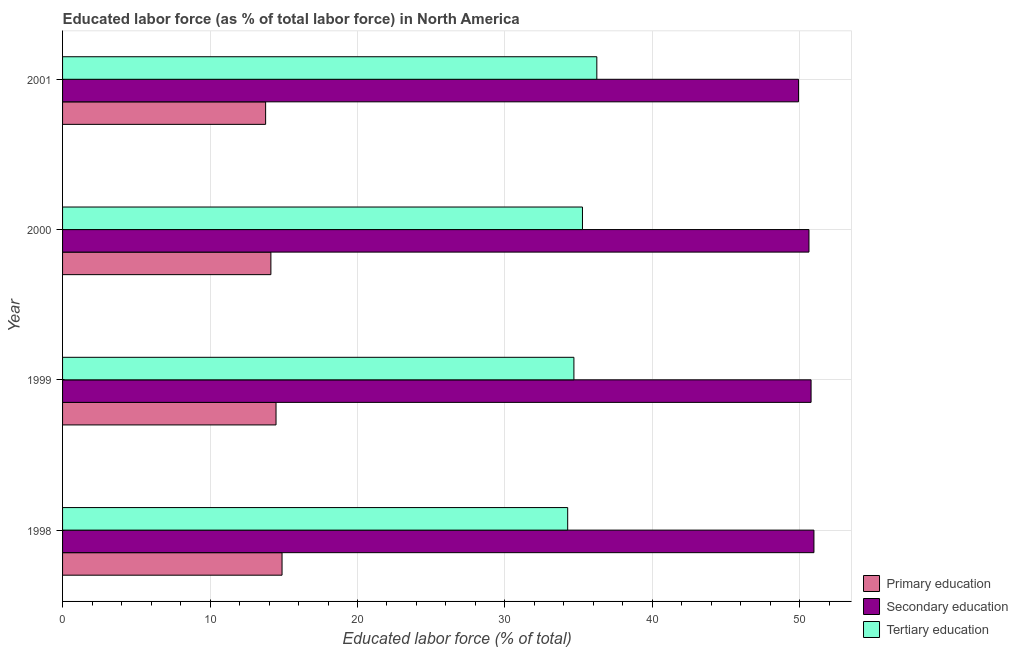How many bars are there on the 3rd tick from the top?
Provide a short and direct response. 3. How many bars are there on the 4th tick from the bottom?
Offer a very short reply. 3. What is the label of the 1st group of bars from the top?
Your answer should be very brief. 2001. What is the percentage of labor force who received primary education in 1999?
Provide a short and direct response. 14.48. Across all years, what is the maximum percentage of labor force who received secondary education?
Your answer should be very brief. 50.95. Across all years, what is the minimum percentage of labor force who received primary education?
Give a very brief answer. 13.77. In which year was the percentage of labor force who received primary education maximum?
Give a very brief answer. 1998. What is the total percentage of labor force who received secondary education in the graph?
Keep it short and to the point. 202.24. What is the difference between the percentage of labor force who received primary education in 1999 and that in 2001?
Provide a succinct answer. 0.7. What is the difference between the percentage of labor force who received tertiary education in 2001 and the percentage of labor force who received secondary education in 2000?
Provide a short and direct response. -14.39. What is the average percentage of labor force who received secondary education per year?
Give a very brief answer. 50.56. In the year 1999, what is the difference between the percentage of labor force who received tertiary education and percentage of labor force who received secondary education?
Your response must be concise. -16.08. What is the ratio of the percentage of labor force who received secondary education in 1998 to that in 2000?
Provide a succinct answer. 1.01. Is the percentage of labor force who received tertiary education in 1999 less than that in 2001?
Ensure brevity in your answer.  Yes. What is the difference between the highest and the second highest percentage of labor force who received secondary education?
Your answer should be compact. 0.19. What is the difference between the highest and the lowest percentage of labor force who received secondary education?
Your answer should be very brief. 1.04. In how many years, is the percentage of labor force who received secondary education greater than the average percentage of labor force who received secondary education taken over all years?
Your answer should be compact. 3. What does the 1st bar from the top in 1998 represents?
Offer a terse response. Tertiary education. What does the 1st bar from the bottom in 1999 represents?
Keep it short and to the point. Primary education. Is it the case that in every year, the sum of the percentage of labor force who received primary education and percentage of labor force who received secondary education is greater than the percentage of labor force who received tertiary education?
Your answer should be very brief. Yes. What is the difference between two consecutive major ticks on the X-axis?
Ensure brevity in your answer.  10. Are the values on the major ticks of X-axis written in scientific E-notation?
Your answer should be very brief. No. Does the graph contain any zero values?
Offer a very short reply. No. Where does the legend appear in the graph?
Offer a very short reply. Bottom right. How many legend labels are there?
Keep it short and to the point. 3. What is the title of the graph?
Provide a succinct answer. Educated labor force (as % of total labor force) in North America. What is the label or title of the X-axis?
Keep it short and to the point. Educated labor force (% of total). What is the label or title of the Y-axis?
Provide a short and direct response. Year. What is the Educated labor force (% of total) in Primary education in 1998?
Keep it short and to the point. 14.88. What is the Educated labor force (% of total) of Secondary education in 1998?
Provide a succinct answer. 50.95. What is the Educated labor force (% of total) of Tertiary education in 1998?
Give a very brief answer. 34.25. What is the Educated labor force (% of total) in Primary education in 1999?
Give a very brief answer. 14.48. What is the Educated labor force (% of total) in Secondary education in 1999?
Your response must be concise. 50.76. What is the Educated labor force (% of total) in Tertiary education in 1999?
Give a very brief answer. 34.68. What is the Educated labor force (% of total) in Primary education in 2000?
Offer a terse response. 14.13. What is the Educated labor force (% of total) in Secondary education in 2000?
Your answer should be very brief. 50.62. What is the Educated labor force (% of total) of Tertiary education in 2000?
Keep it short and to the point. 35.26. What is the Educated labor force (% of total) of Primary education in 2001?
Provide a succinct answer. 13.77. What is the Educated labor force (% of total) in Secondary education in 2001?
Provide a succinct answer. 49.91. What is the Educated labor force (% of total) in Tertiary education in 2001?
Give a very brief answer. 36.23. Across all years, what is the maximum Educated labor force (% of total) of Primary education?
Keep it short and to the point. 14.88. Across all years, what is the maximum Educated labor force (% of total) of Secondary education?
Provide a short and direct response. 50.95. Across all years, what is the maximum Educated labor force (% of total) of Tertiary education?
Give a very brief answer. 36.23. Across all years, what is the minimum Educated labor force (% of total) of Primary education?
Your answer should be compact. 13.77. Across all years, what is the minimum Educated labor force (% of total) in Secondary education?
Provide a succinct answer. 49.91. Across all years, what is the minimum Educated labor force (% of total) of Tertiary education?
Your answer should be compact. 34.25. What is the total Educated labor force (% of total) of Primary education in the graph?
Ensure brevity in your answer.  57.26. What is the total Educated labor force (% of total) of Secondary education in the graph?
Provide a short and direct response. 202.24. What is the total Educated labor force (% of total) in Tertiary education in the graph?
Ensure brevity in your answer.  140.42. What is the difference between the Educated labor force (% of total) of Primary education in 1998 and that in 1999?
Make the answer very short. 0.41. What is the difference between the Educated labor force (% of total) in Secondary education in 1998 and that in 1999?
Provide a short and direct response. 0.19. What is the difference between the Educated labor force (% of total) of Tertiary education in 1998 and that in 1999?
Offer a terse response. -0.42. What is the difference between the Educated labor force (% of total) of Primary education in 1998 and that in 2000?
Keep it short and to the point. 0.76. What is the difference between the Educated labor force (% of total) in Secondary education in 1998 and that in 2000?
Provide a short and direct response. 0.34. What is the difference between the Educated labor force (% of total) of Tertiary education in 1998 and that in 2000?
Provide a short and direct response. -1. What is the difference between the Educated labor force (% of total) in Primary education in 1998 and that in 2001?
Provide a succinct answer. 1.11. What is the difference between the Educated labor force (% of total) in Secondary education in 1998 and that in 2001?
Your answer should be compact. 1.04. What is the difference between the Educated labor force (% of total) in Tertiary education in 1998 and that in 2001?
Make the answer very short. -1.98. What is the difference between the Educated labor force (% of total) in Primary education in 1999 and that in 2000?
Your answer should be compact. 0.35. What is the difference between the Educated labor force (% of total) of Secondary education in 1999 and that in 2000?
Your answer should be compact. 0.14. What is the difference between the Educated labor force (% of total) of Tertiary education in 1999 and that in 2000?
Provide a succinct answer. -0.58. What is the difference between the Educated labor force (% of total) of Primary education in 1999 and that in 2001?
Provide a short and direct response. 0.71. What is the difference between the Educated labor force (% of total) of Secondary education in 1999 and that in 2001?
Your answer should be compact. 0.85. What is the difference between the Educated labor force (% of total) in Tertiary education in 1999 and that in 2001?
Give a very brief answer. -1.55. What is the difference between the Educated labor force (% of total) of Primary education in 2000 and that in 2001?
Ensure brevity in your answer.  0.36. What is the difference between the Educated labor force (% of total) in Secondary education in 2000 and that in 2001?
Keep it short and to the point. 0.71. What is the difference between the Educated labor force (% of total) of Tertiary education in 2000 and that in 2001?
Your response must be concise. -0.97. What is the difference between the Educated labor force (% of total) in Primary education in 1998 and the Educated labor force (% of total) in Secondary education in 1999?
Offer a very short reply. -35.88. What is the difference between the Educated labor force (% of total) of Primary education in 1998 and the Educated labor force (% of total) of Tertiary education in 1999?
Offer a terse response. -19.79. What is the difference between the Educated labor force (% of total) in Secondary education in 1998 and the Educated labor force (% of total) in Tertiary education in 1999?
Your answer should be compact. 16.28. What is the difference between the Educated labor force (% of total) of Primary education in 1998 and the Educated labor force (% of total) of Secondary education in 2000?
Your response must be concise. -35.73. What is the difference between the Educated labor force (% of total) of Primary education in 1998 and the Educated labor force (% of total) of Tertiary education in 2000?
Offer a very short reply. -20.37. What is the difference between the Educated labor force (% of total) in Secondary education in 1998 and the Educated labor force (% of total) in Tertiary education in 2000?
Give a very brief answer. 15.7. What is the difference between the Educated labor force (% of total) in Primary education in 1998 and the Educated labor force (% of total) in Secondary education in 2001?
Offer a very short reply. -35.03. What is the difference between the Educated labor force (% of total) of Primary education in 1998 and the Educated labor force (% of total) of Tertiary education in 2001?
Provide a short and direct response. -21.35. What is the difference between the Educated labor force (% of total) in Secondary education in 1998 and the Educated labor force (% of total) in Tertiary education in 2001?
Provide a succinct answer. 14.72. What is the difference between the Educated labor force (% of total) of Primary education in 1999 and the Educated labor force (% of total) of Secondary education in 2000?
Offer a very short reply. -36.14. What is the difference between the Educated labor force (% of total) of Primary education in 1999 and the Educated labor force (% of total) of Tertiary education in 2000?
Your answer should be compact. -20.78. What is the difference between the Educated labor force (% of total) of Secondary education in 1999 and the Educated labor force (% of total) of Tertiary education in 2000?
Offer a terse response. 15.5. What is the difference between the Educated labor force (% of total) of Primary education in 1999 and the Educated labor force (% of total) of Secondary education in 2001?
Offer a terse response. -35.43. What is the difference between the Educated labor force (% of total) of Primary education in 1999 and the Educated labor force (% of total) of Tertiary education in 2001?
Keep it short and to the point. -21.75. What is the difference between the Educated labor force (% of total) in Secondary education in 1999 and the Educated labor force (% of total) in Tertiary education in 2001?
Provide a short and direct response. 14.53. What is the difference between the Educated labor force (% of total) of Primary education in 2000 and the Educated labor force (% of total) of Secondary education in 2001?
Provide a short and direct response. -35.78. What is the difference between the Educated labor force (% of total) of Primary education in 2000 and the Educated labor force (% of total) of Tertiary education in 2001?
Provide a short and direct response. -22.1. What is the difference between the Educated labor force (% of total) of Secondary education in 2000 and the Educated labor force (% of total) of Tertiary education in 2001?
Provide a succinct answer. 14.39. What is the average Educated labor force (% of total) of Primary education per year?
Offer a very short reply. 14.31. What is the average Educated labor force (% of total) of Secondary education per year?
Ensure brevity in your answer.  50.56. What is the average Educated labor force (% of total) of Tertiary education per year?
Provide a short and direct response. 35.1. In the year 1998, what is the difference between the Educated labor force (% of total) of Primary education and Educated labor force (% of total) of Secondary education?
Give a very brief answer. -36.07. In the year 1998, what is the difference between the Educated labor force (% of total) in Primary education and Educated labor force (% of total) in Tertiary education?
Your answer should be very brief. -19.37. In the year 1998, what is the difference between the Educated labor force (% of total) in Secondary education and Educated labor force (% of total) in Tertiary education?
Your response must be concise. 16.7. In the year 1999, what is the difference between the Educated labor force (% of total) in Primary education and Educated labor force (% of total) in Secondary education?
Ensure brevity in your answer.  -36.28. In the year 1999, what is the difference between the Educated labor force (% of total) in Primary education and Educated labor force (% of total) in Tertiary education?
Keep it short and to the point. -20.2. In the year 1999, what is the difference between the Educated labor force (% of total) in Secondary education and Educated labor force (% of total) in Tertiary education?
Provide a succinct answer. 16.08. In the year 2000, what is the difference between the Educated labor force (% of total) in Primary education and Educated labor force (% of total) in Secondary education?
Give a very brief answer. -36.49. In the year 2000, what is the difference between the Educated labor force (% of total) of Primary education and Educated labor force (% of total) of Tertiary education?
Make the answer very short. -21.13. In the year 2000, what is the difference between the Educated labor force (% of total) in Secondary education and Educated labor force (% of total) in Tertiary education?
Your answer should be very brief. 15.36. In the year 2001, what is the difference between the Educated labor force (% of total) in Primary education and Educated labor force (% of total) in Secondary education?
Your answer should be very brief. -36.14. In the year 2001, what is the difference between the Educated labor force (% of total) in Primary education and Educated labor force (% of total) in Tertiary education?
Give a very brief answer. -22.46. In the year 2001, what is the difference between the Educated labor force (% of total) in Secondary education and Educated labor force (% of total) in Tertiary education?
Provide a succinct answer. 13.68. What is the ratio of the Educated labor force (% of total) of Primary education in 1998 to that in 1999?
Offer a terse response. 1.03. What is the ratio of the Educated labor force (% of total) in Tertiary education in 1998 to that in 1999?
Ensure brevity in your answer.  0.99. What is the ratio of the Educated labor force (% of total) in Primary education in 1998 to that in 2000?
Give a very brief answer. 1.05. What is the ratio of the Educated labor force (% of total) in Tertiary education in 1998 to that in 2000?
Keep it short and to the point. 0.97. What is the ratio of the Educated labor force (% of total) in Primary education in 1998 to that in 2001?
Your answer should be compact. 1.08. What is the ratio of the Educated labor force (% of total) in Secondary education in 1998 to that in 2001?
Provide a succinct answer. 1.02. What is the ratio of the Educated labor force (% of total) of Tertiary education in 1998 to that in 2001?
Give a very brief answer. 0.95. What is the ratio of the Educated labor force (% of total) in Primary education in 1999 to that in 2000?
Your response must be concise. 1.02. What is the ratio of the Educated labor force (% of total) of Tertiary education in 1999 to that in 2000?
Offer a terse response. 0.98. What is the ratio of the Educated labor force (% of total) of Primary education in 1999 to that in 2001?
Provide a short and direct response. 1.05. What is the ratio of the Educated labor force (% of total) of Tertiary education in 1999 to that in 2001?
Give a very brief answer. 0.96. What is the ratio of the Educated labor force (% of total) in Primary education in 2000 to that in 2001?
Offer a terse response. 1.03. What is the ratio of the Educated labor force (% of total) in Secondary education in 2000 to that in 2001?
Give a very brief answer. 1.01. What is the ratio of the Educated labor force (% of total) in Tertiary education in 2000 to that in 2001?
Offer a terse response. 0.97. What is the difference between the highest and the second highest Educated labor force (% of total) in Primary education?
Your response must be concise. 0.41. What is the difference between the highest and the second highest Educated labor force (% of total) in Secondary education?
Provide a short and direct response. 0.19. What is the difference between the highest and the second highest Educated labor force (% of total) in Tertiary education?
Offer a terse response. 0.97. What is the difference between the highest and the lowest Educated labor force (% of total) of Primary education?
Your response must be concise. 1.11. What is the difference between the highest and the lowest Educated labor force (% of total) of Secondary education?
Your response must be concise. 1.04. What is the difference between the highest and the lowest Educated labor force (% of total) of Tertiary education?
Offer a terse response. 1.98. 